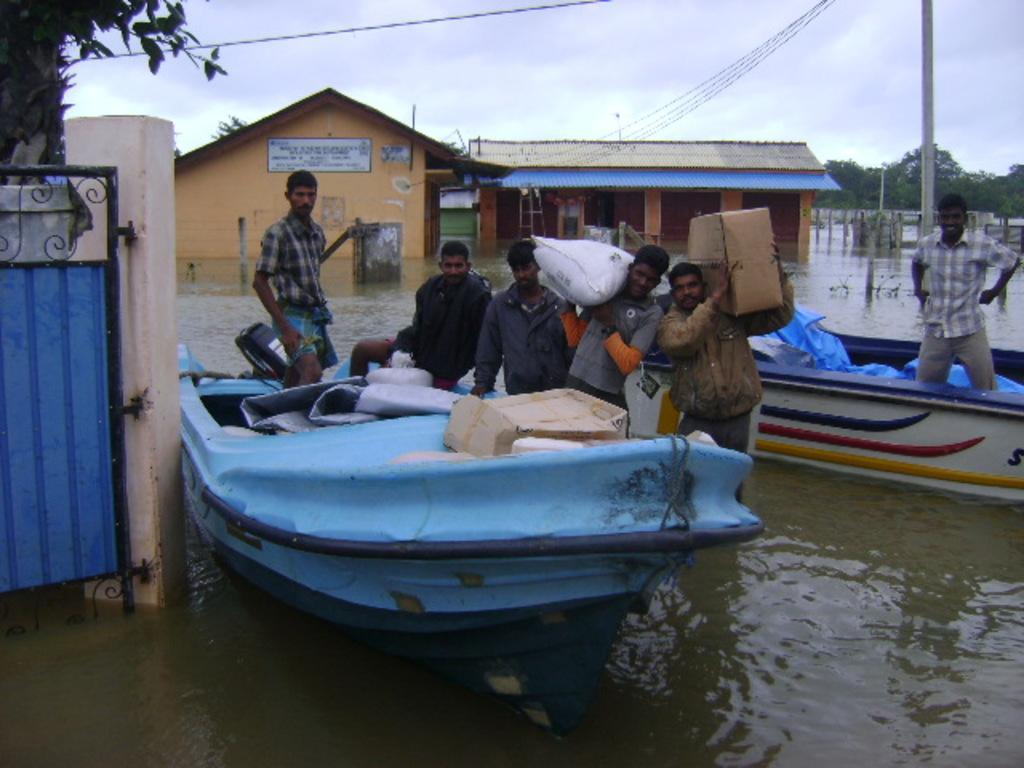How would you summarize this image in a sentence or two? In this image I can see the water, few boats which are blue, white, red, yellow and black in color on the surface of the water. I can see few persons standing in the water and few persons in the boat. In the background I can see few buildings, a pole, few wires, few trees and the sky. 